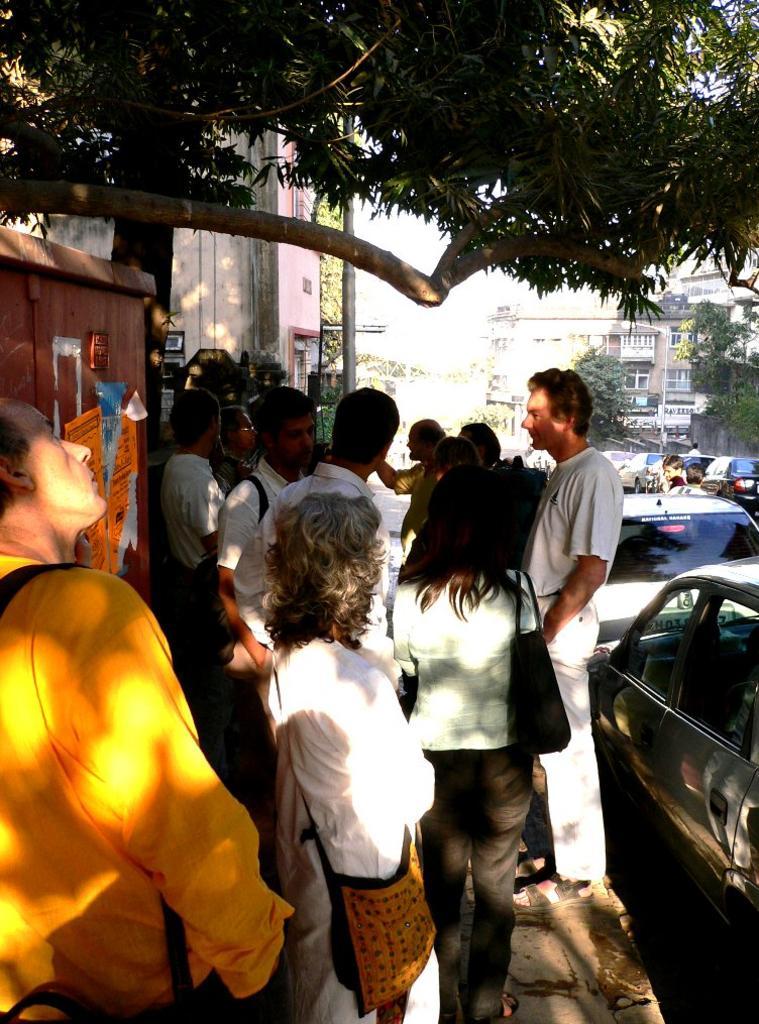How would you summarize this image in a sentence or two? In the center of the image we can see a shed, rods. In the background of the image we can see the buildings, windows, trees, pole, posters on the wall, vehicles and some people are standing and some of them are wearing bags. At the bottom of the image we can see the pavement. In the middle of the image we can see the sky. 